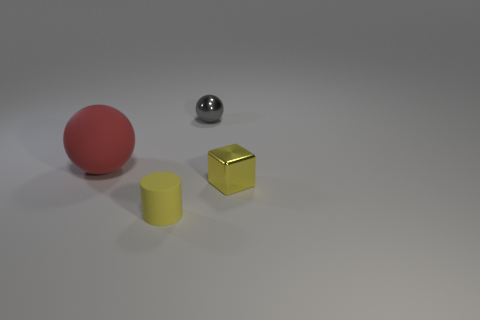Add 1 small gray metallic things. How many objects exist? 5 Subtract all gray balls. How many balls are left? 1 Subtract all cylinders. How many objects are left? 3 Add 1 big red matte spheres. How many big red matte spheres exist? 2 Subtract 0 blue spheres. How many objects are left? 4 Subtract all tiny red matte cylinders. Subtract all big red balls. How many objects are left? 3 Add 3 tiny yellow matte cylinders. How many tiny yellow matte cylinders are left? 4 